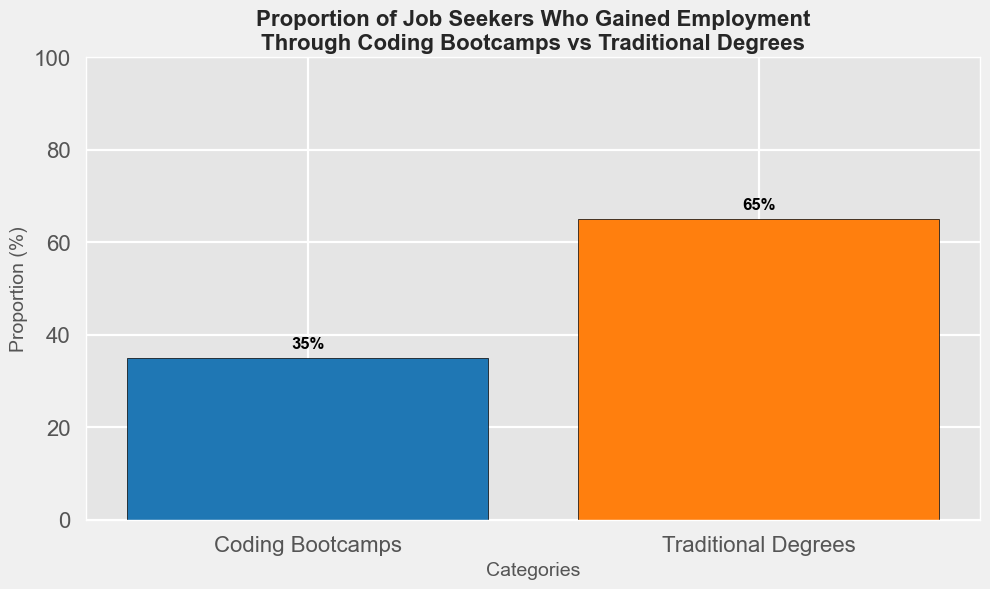Which category has the highest proportion of job seekers who gained employment? Observe the heights of the bars to see which one is taller. The bar for Traditional Degrees is higher.
Answer: Traditional Degrees What is the proportion of job seekers who gained employment through coding bootcamps? Look at the height label on the bootcamp bar pointing to the percentage.
Answer: 35% By how much does the proportion of job seekers gaining employment through traditional degrees exceed those from coding bootcamps? Subtract the proportion of coding bootcamps (35%) from traditional degrees (65%). Calculation: 65% - 35% = 30%
Answer: 30% What is the combined proportion of job seekers who gained employment either through coding bootcamps or traditional degrees? Add the two proportions: 35% (coding bootcamps) + 65% (traditional degrees). Calculation: 35% + 65% = 100%
Answer: 100% Which bar is colored blue? Observe the color representation in the bar chart. The bar for coding bootcamps is colored blue.
Answer: Coding Bootcamps Is the proportion of job seekers gaining employment through traditional degrees greater than twice the proportion for coding bootcamps? Calculate twice the proportion for coding bootcamps: 2 * 35% = 70%. The proportion for traditional degrees is 65%. Compare the two values: 65% < 70%.
Answer: No, it is not What is the difference in height between the two bars in the chart? Measure the difference in bar heights, with traditional degrees (65%) and coding bootcamps (35%). Calculation: 65% - 35% = 30%
Answer: 30% 